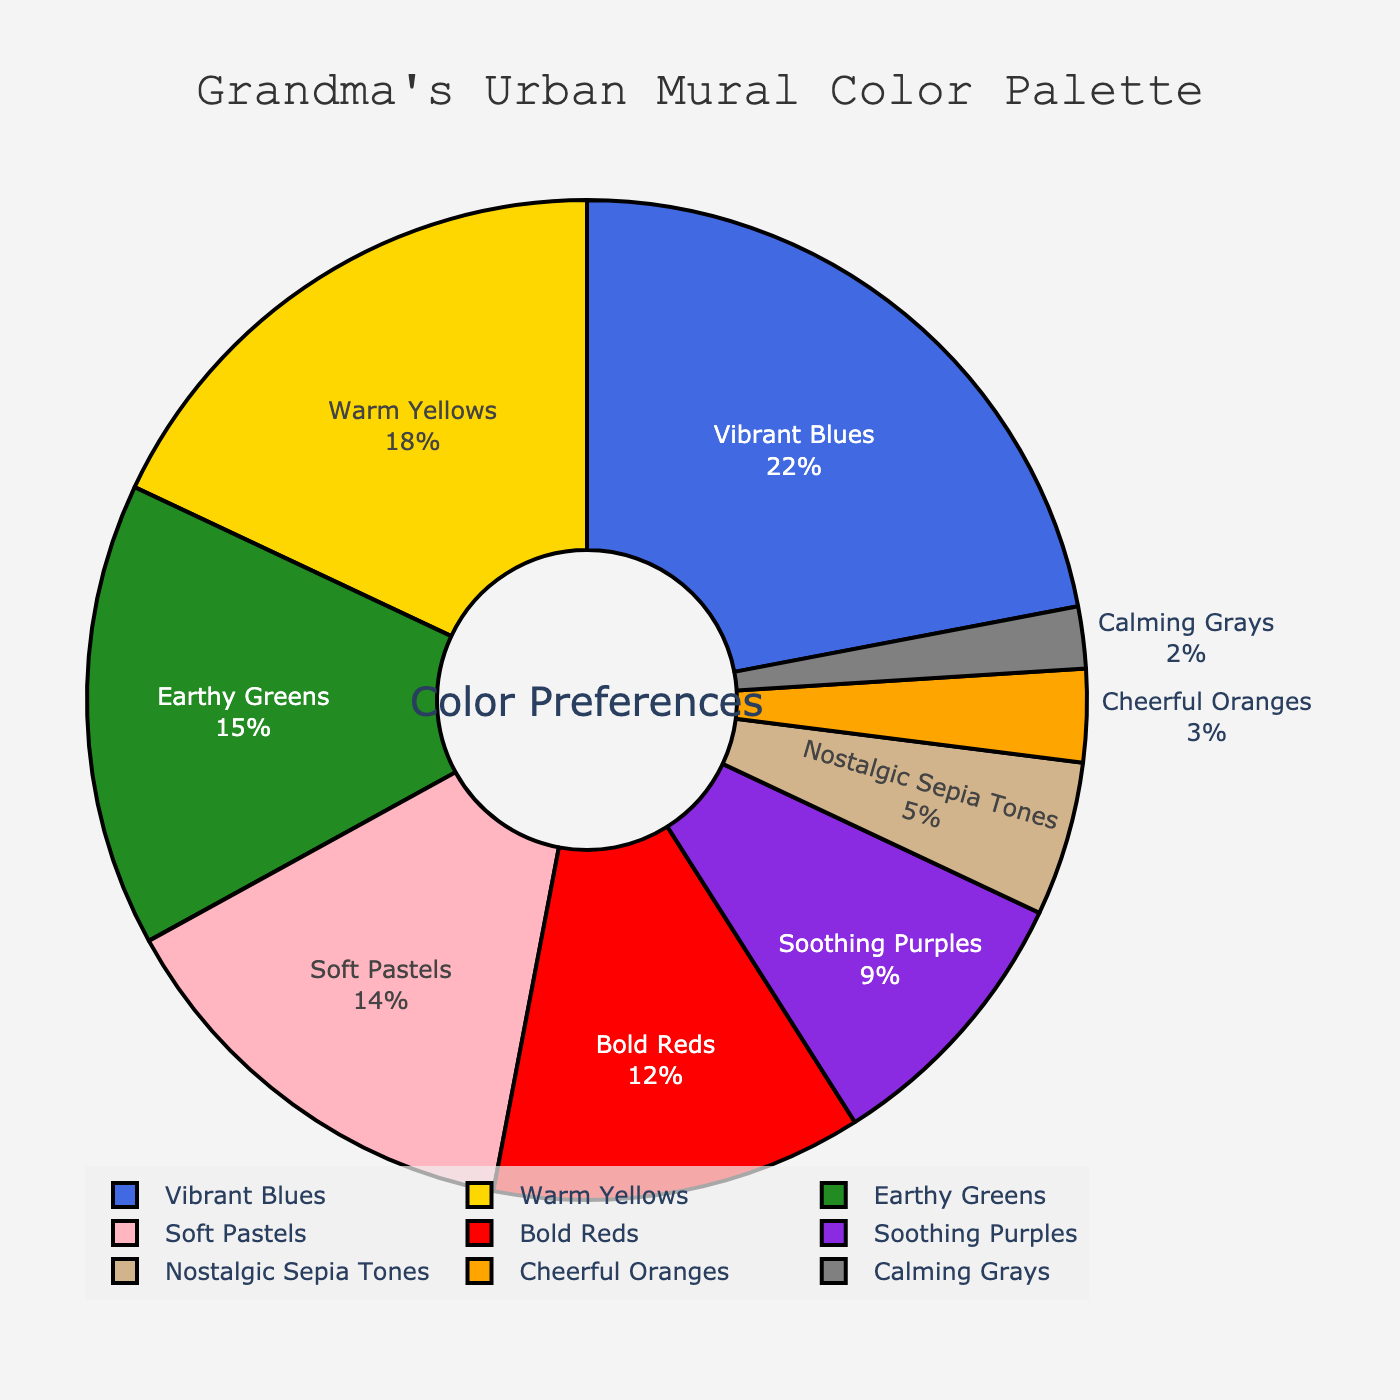what color palette has the highest preference? The segment labeled 'Vibrant Blues' covers the largest area of the pie chart and has the highest percentage, which is 22%.
Answer: Vibrant Blues which color has the smallest percentage preference? The segment labeled 'Calming Grays' has the smallest slice in the pie chart, representing 2% of the total preferences.
Answer: Calming Grays what is the combined percentage of Warm Yellows and Bold Reds? Add the percentages of Warm Yellows (18%) and Bold Reds (12%): 18% + 12% = 30%.
Answer: 30% how much more preferred are Vibrant Blues compared to Cheerful Oranges? Calculate the difference between the percentages of Vibrant Blues (22%) and Cheerful Oranges (3%): 22% - 3% = 19%.
Answer: 19% which colors together make up exactly half of the preferences? Add up the percentages: Vibrant Blues (22%) + Warm Yellows (18%) + Earthy Greens (15%) = 55%. However, slightly adjust this to Soft Pastels (14%) for slightly less than half: 22% + 18% + 14% = 54%. Lowering it more accurately to Bold Reds (12%): 22% + 18% + 12% = 52%. Adjusting further down might get Earthy Greens and Soft Pastels combined. So, Warm Yellows + Earthy Greens + Soft Pastels = 18% + 15% + 14% = 47%, adding Bold Reds will get close to half: 18% + 15% + 14% + 12% = 59%. Hence, the exact half combined calculation might involve several close values together
Answer: Multiple summaries might get close, none exact upto 50% alone which colors are less preferred than Bold Reds? The slices corresponding to less than 12% are Soothing Purples (9%), Nostalgic Sepia Tones (5%), Cheerful Oranges (3%) and Calming Grays (2%). All these four categories have smaller slices compared to Bold Reds.
Answer: Soothing Purples, Nostalgic Sepia Tones, Cheerful Oranges, Calming Grays what is the difference in percentage between Earthy Greens and Nostalgic Sepia Tones? Subtract the percentage of Nostalgic Sepia Tones (5%) from Earthy Greens (15%): 15% - 5% = 10%.
Answer: 10% which palette colors combined exceed more than all the percentage of Bold Reds and Soothing Purples? Sum of Bold Reds (12%) and Soothing Purples (9%) is 12% + 9% = 21%. Adding Vibrant Blues and Soft pastels (12%+14%=26%) or Warm yellows and Earthy greens (33%) both exceed sum of Bold Reds and Soothing Purples.
Answer: Vibrant Blues and various combinations including yellow, greens which categories are represented similarly in terms of percentage? Find segments with close percentages: Soft Pastels (14%) and Bold Reds (12%) are close but Warm Yellows (specifically has high similarity). Earthy Greens (15%), Soft Pastels (14%), and Bold Reds (12%) have close representation.
Answer: Earthy Greens and Soft Pastels, Bold Reds and Warm Yellows total preference percentages for least preferred colors combined Combine percentages of Soothing Purples (9%), Nostalgic Sepia Tones (5%), Cheerful Oranges (3%), Calming Grays (2%): 9% + 5% + 3% + 2% = 19%.
Answer: 19% 